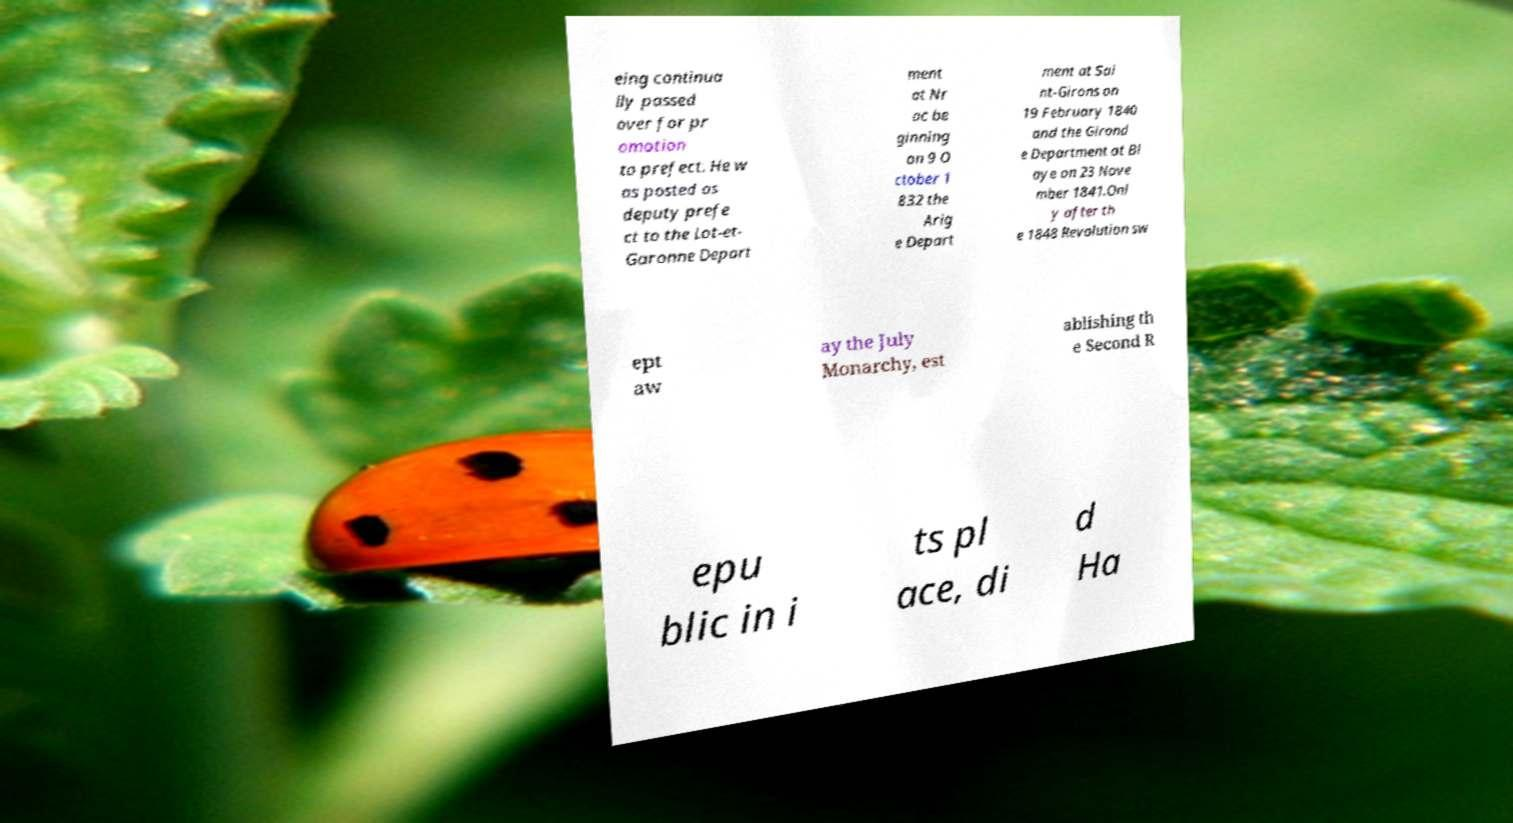What messages or text are displayed in this image? I need them in a readable, typed format. eing continua lly passed over for pr omotion to prefect. He w as posted as deputy prefe ct to the Lot-et- Garonne Depart ment at Nr ac be ginning on 9 O ctober 1 832 the Arig e Depart ment at Sai nt-Girons on 19 February 1840 and the Girond e Department at Bl aye on 23 Nove mber 1841.Onl y after th e 1848 Revolution sw ept aw ay the July Monarchy, est ablishing th e Second R epu blic in i ts pl ace, di d Ha 